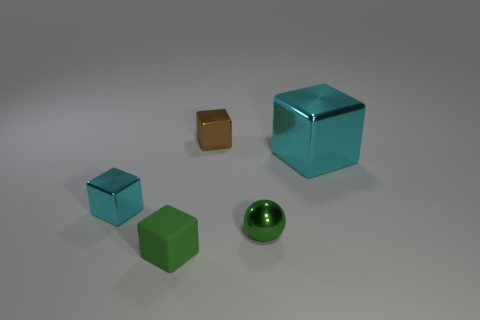Add 2 large blue cylinders. How many objects exist? 7 Subtract all spheres. How many objects are left? 4 Subtract 0 red blocks. How many objects are left? 5 Subtract all small cyan cubes. Subtract all blocks. How many objects are left? 0 Add 4 small green matte cubes. How many small green matte cubes are left? 5 Add 3 tiny brown objects. How many tiny brown objects exist? 4 